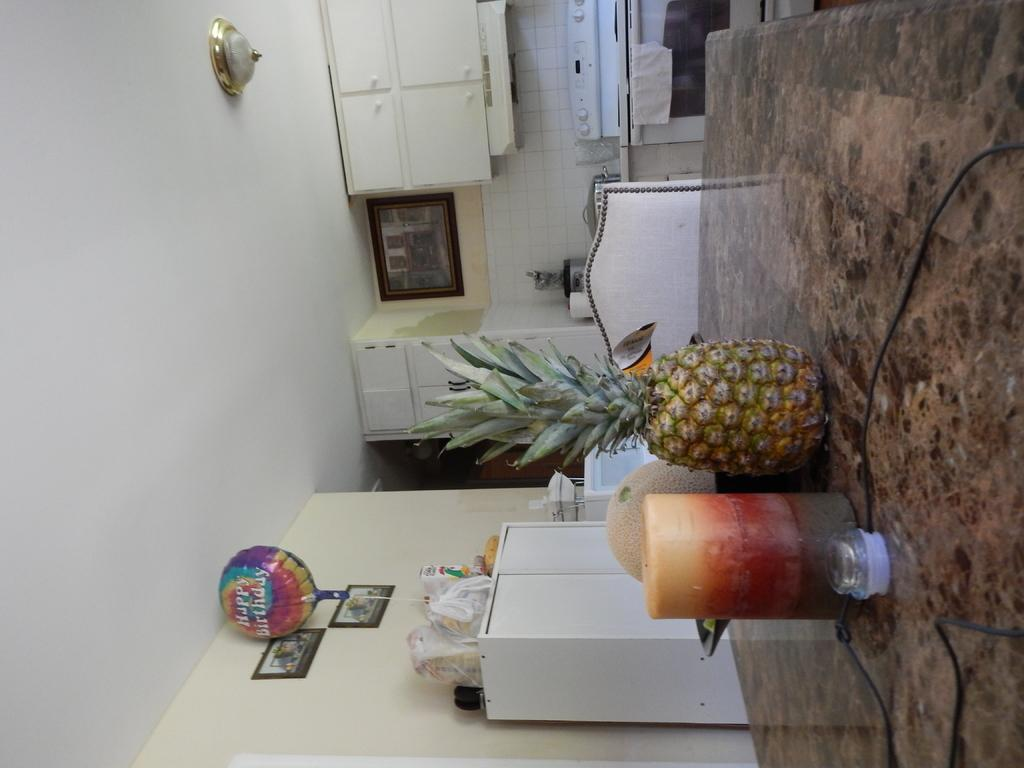What is placed on the platform in the image? There are fruits on a platform in the image. What type of furniture can be seen in the image? There is a chair in the image. What appliances are present in the image? There is a stove and an oven in the image. What type of decorative items are in the image? There are frames in the image. What type of storage units are in the image? There are cupboards in the image. What type of textile is present in the image? There is a cloth in the image. What is visible on the ceiling in the image? The ceiling is visible in the image. What is visible on the wall in the image? There is a wall in the image. How does the whip make the fruits on the platform laugh in the image? There is no whip or laughter present in the image. The image only features fruits on a platform, a chair, cupboards, frames, packets, a balloon, a stove, an oven, a cloth, the ceiling, and a wall. 